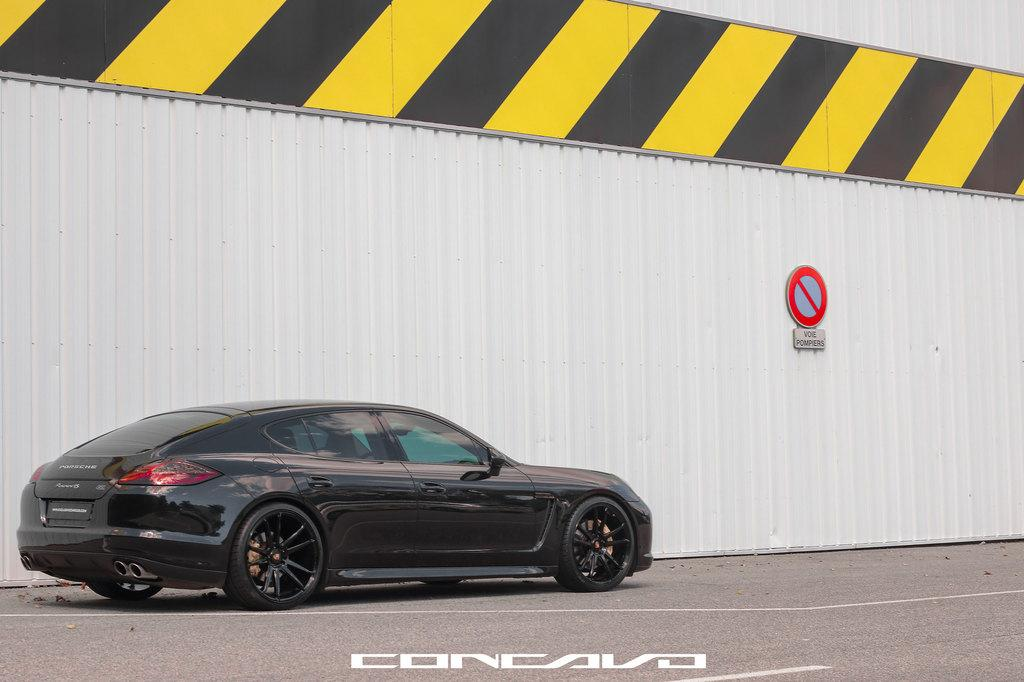What is the main subject on the left side of the image? There is a car on the left side of the image. What color is the car? The car is black in color. What other structure is visible in the image? There is a dock in the image. Where is the dock located in the image? The dock is in the center of the image. What type of fruit is growing on the car in the image? There is no fruit growing on the car in the image. Can you see a snail crawling on the dock in the image? There is no snail visible on the dock in the image. 